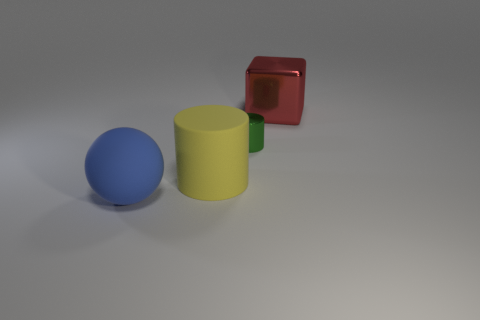What is the size of the thing that is left of the green metallic cylinder and right of the big blue matte ball?
Your answer should be very brief. Large. What number of other green things have the same material as the green object?
Offer a terse response. 0. The small cylinder is what color?
Provide a succinct answer. Green. Do the shiny object that is behind the metal cylinder and the big blue thing have the same shape?
Give a very brief answer. No. What number of things are either rubber things to the right of the rubber ball or tiny matte cubes?
Keep it short and to the point. 1. Are there any tiny green shiny things of the same shape as the red object?
Offer a terse response. No. There is a yellow matte thing that is the same size as the ball; what shape is it?
Offer a very short reply. Cylinder. There is a matte thing that is in front of the big matte thing that is right of the object in front of the big matte cylinder; what is its shape?
Provide a short and direct response. Sphere. There is a large yellow rubber object; does it have the same shape as the rubber object in front of the large yellow rubber object?
Keep it short and to the point. No. How many small things are either rubber cylinders or matte objects?
Offer a terse response. 0. 